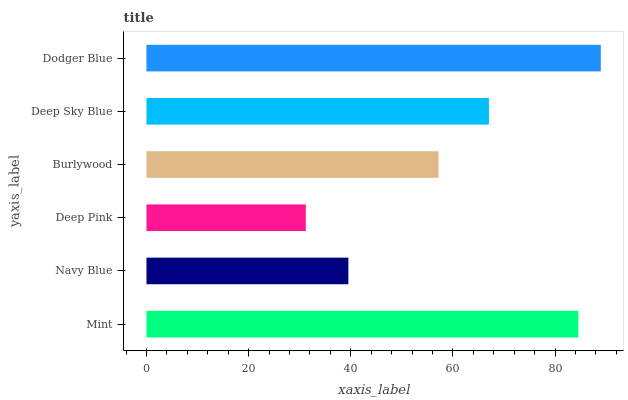Is Deep Pink the minimum?
Answer yes or no. Yes. Is Dodger Blue the maximum?
Answer yes or no. Yes. Is Navy Blue the minimum?
Answer yes or no. No. Is Navy Blue the maximum?
Answer yes or no. No. Is Mint greater than Navy Blue?
Answer yes or no. Yes. Is Navy Blue less than Mint?
Answer yes or no. Yes. Is Navy Blue greater than Mint?
Answer yes or no. No. Is Mint less than Navy Blue?
Answer yes or no. No. Is Deep Sky Blue the high median?
Answer yes or no. Yes. Is Burlywood the low median?
Answer yes or no. Yes. Is Mint the high median?
Answer yes or no. No. Is Deep Sky Blue the low median?
Answer yes or no. No. 